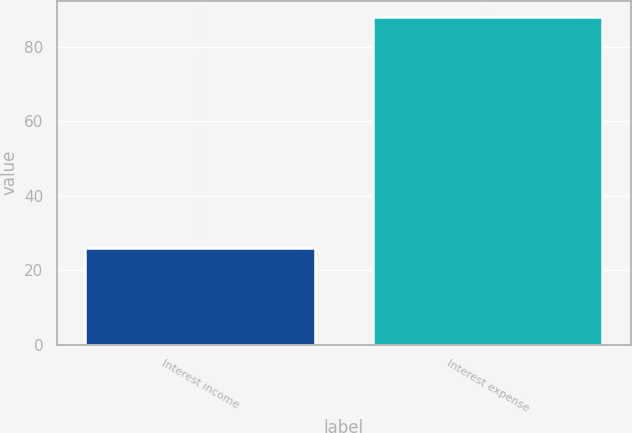Convert chart. <chart><loc_0><loc_0><loc_500><loc_500><bar_chart><fcel>Interest income<fcel>Interest expense<nl><fcel>26<fcel>88<nl></chart> 